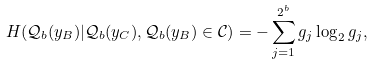Convert formula to latex. <formula><loc_0><loc_0><loc_500><loc_500>H ( \mathcal { Q } _ { b } ( y _ { B } ) | \mathcal { Q } _ { b } ( y _ { C } ) , \mathcal { Q } _ { b } ( y _ { B } ) \in \mathcal { C } ) = - \sum _ { j = 1 } ^ { 2 ^ { b } } g _ { j } \log _ { 2 } { g _ { j } } ,</formula> 